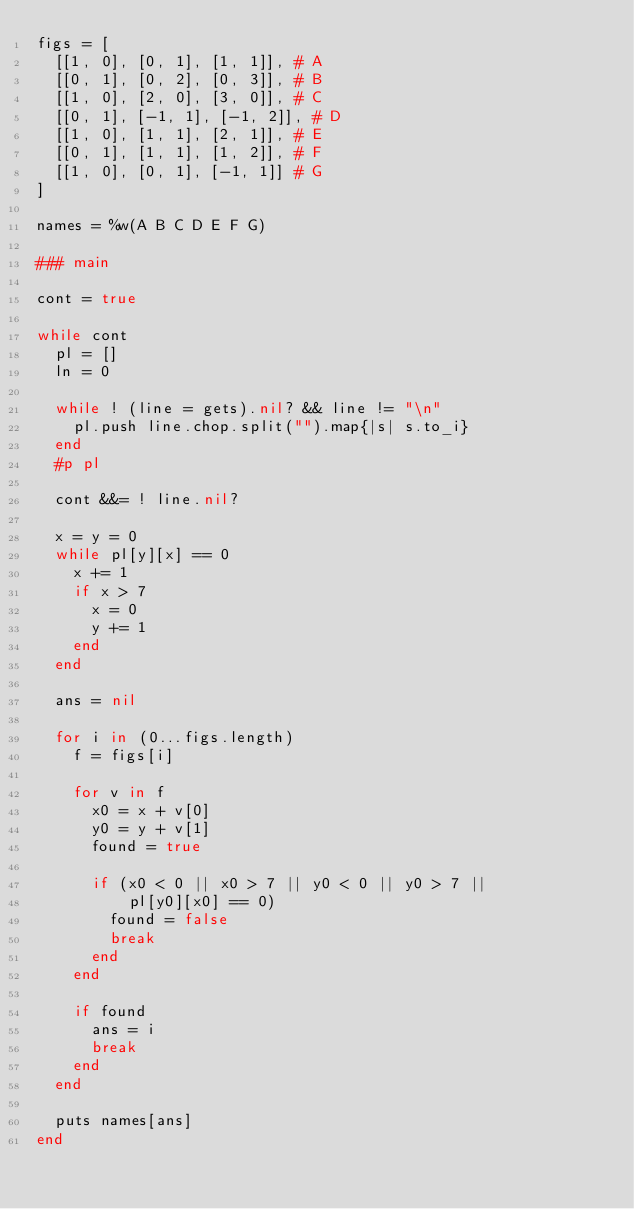<code> <loc_0><loc_0><loc_500><loc_500><_Ruby_>figs = [
  [[1, 0], [0, 1], [1, 1]],	# A
  [[0, 1], [0, 2], [0, 3]],	# B
  [[1, 0], [2, 0], [3, 0]],	# C
  [[0, 1], [-1, 1], [-1, 2]],	# D
  [[1, 0], [1, 1], [2, 1]],	# E
  [[0, 1], [1, 1], [1, 2]],	# F
  [[1, 0], [0, 1], [-1, 1]]	# G
]

names = %w(A B C D E F G)

### main

cont = true

while cont
  pl = []
  ln = 0

  while ! (line = gets).nil? && line != "\n"
    pl.push line.chop.split("").map{|s| s.to_i}
  end
  #p pl

  cont &&= ! line.nil?

  x = y = 0
  while pl[y][x] == 0
    x += 1
    if x > 7
      x = 0
      y += 1
    end
  end

  ans = nil

  for i in (0...figs.length)
    f = figs[i]

    for v in f
      x0 = x + v[0]
      y0 = y + v[1]
      found = true

      if (x0 < 0 || x0 > 7 || y0 < 0 || y0 > 7 ||
          pl[y0][x0] == 0)
        found = false
        break
      end
    end

    if found
      ans = i
      break
    end
  end

  puts names[ans]
end</code> 